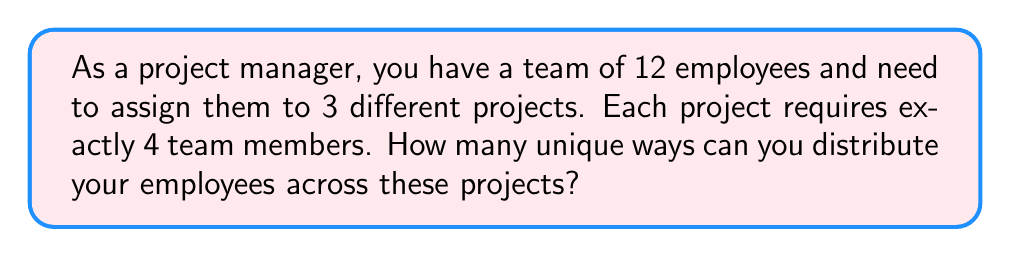Teach me how to tackle this problem. Let's approach this step-by-step:

1) This is a combination problem, as the order within each project team doesn't matter.

2) We can think of this as choosing 4 employees for the first project, then 4 from the remaining 8 for the second project. The last 4 will automatically be assigned to the third project.

3) For the first project, we choose 4 employees out of 12. This can be done in $\binom{12}{4}$ ways.

4) For the second project, we choose 4 employees out of the remaining 8. This can be done in $\binom{8}{4}$ ways.

5) The third project team is determined automatically once the first two are chosen.

6) By the multiplication principle, the total number of ways to assign the teams is:

   $$\binom{12}{4} \cdot \binom{8}{4}$$

7) Let's calculate this:
   
   $$\binom{12}{4} = \frac{12!}{4!(12-4)!} = \frac{12!}{4!8!} = 495$$
   
   $$\binom{8}{4} = \frac{8!}{4!(8-4)!} = \frac{8!}{4!4!} = 70$$

8) Therefore, the total number of unique team combinations is:

   $$495 \cdot 70 = 34,650$$

However, this counts each assignment six times because the order of choosing the projects doesn't matter (3! = 6 ways to order the projects). To get the actual number of unique assignments, we need to divide by 6:

$$\frac{34,650}{6} = 5,775$$
Answer: $5,775$ unique team combinations 